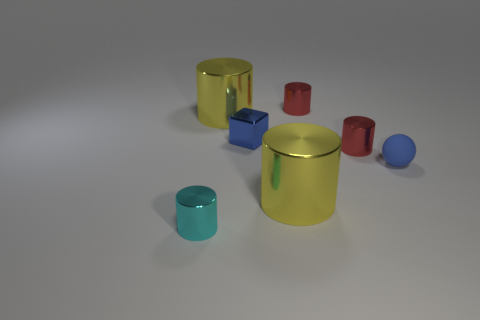The cyan thing that is the same size as the sphere is what shape?
Provide a succinct answer. Cylinder. What number of other things are there of the same color as the small ball?
Your answer should be compact. 1. How many rubber spheres are there?
Ensure brevity in your answer.  1. What number of metallic cylinders are in front of the sphere and to the left of the tiny blue block?
Your answer should be compact. 1. What is the small cyan cylinder made of?
Offer a very short reply. Metal. Are any blocks visible?
Your answer should be very brief. Yes. The big metal cylinder that is behind the cube is what color?
Keep it short and to the point. Yellow. There is a big yellow metal thing that is behind the blue object to the left of the small rubber ball; what number of tiny red metallic objects are in front of it?
Your answer should be very brief. 1. Is the cyan cylinder made of the same material as the large cylinder that is behind the rubber sphere?
Offer a terse response. Yes. Is the number of large yellow cylinders that are behind the cyan cylinder greater than the number of tiny cyan metallic things on the right side of the block?
Provide a succinct answer. Yes. 